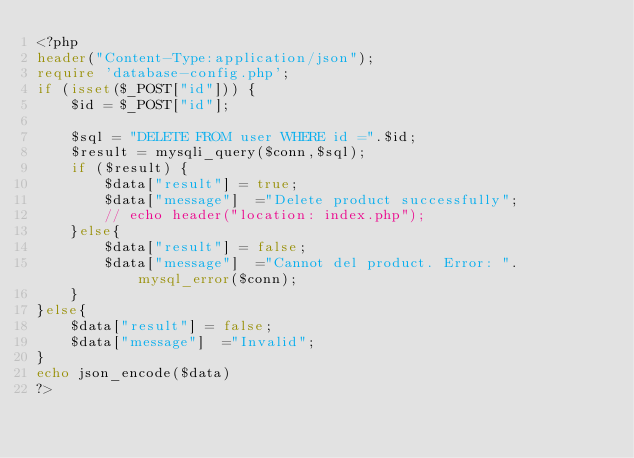Convert code to text. <code><loc_0><loc_0><loc_500><loc_500><_PHP_><?php
header("Content-Type:application/json");
require 'database-config.php';
if (isset($_POST["id"])) {
	$id = $_POST["id"];

    $sql = "DELETE FROM user WHERE id =".$id;
    $result = mysqli_query($conn,$sql);
    if ($result) {
        $data["result"] = true;
        $data["message"]  ="Delete product successfully";
        // echo header("location: index.php");
    }else{
        $data["result"] = false;
        $data["message"]  ="Cannot del product. Error: ".mysql_error($conn);
    }
}else{
    $data["result"] = false;
    $data["message"]  ="Invalid";
}
echo json_encode($data)
?></code> 